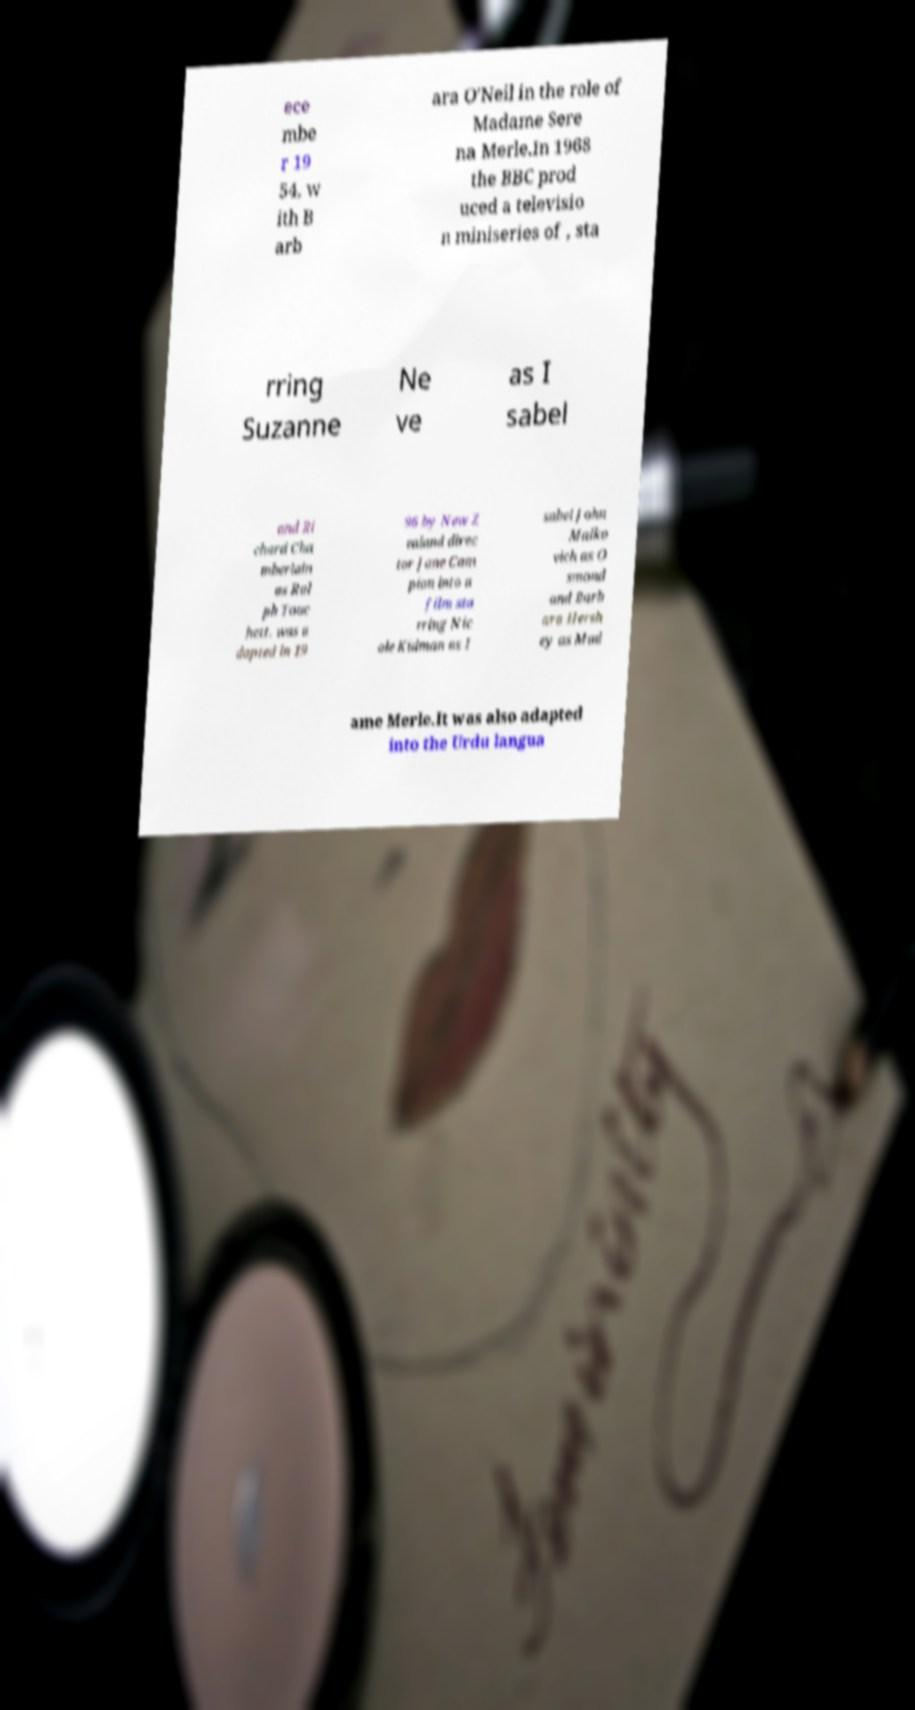For documentation purposes, I need the text within this image transcribed. Could you provide that? ece mbe r 19 54, w ith B arb ara O'Neil in the role of Madame Sere na Merle.In 1968 the BBC prod uced a televisio n miniseries of , sta rring Suzanne Ne ve as I sabel and Ri chard Cha mberlain as Ral ph Touc hett. was a dapted in 19 96 by New Z ealand direc tor Jane Cam pion into a film sta rring Nic ole Kidman as I sabel John Malko vich as O smond and Barb ara Hersh ey as Mad ame Merle.It was also adapted into the Urdu langua 